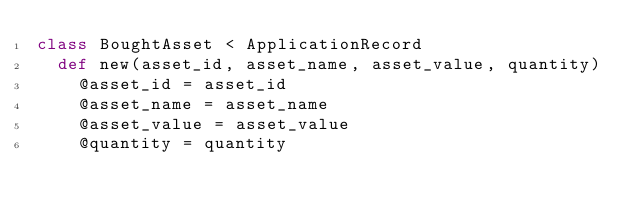<code> <loc_0><loc_0><loc_500><loc_500><_Ruby_>class BoughtAsset < ApplicationRecord
	def new(asset_id, asset_name, asset_value, quantity)
		@asset_id = asset_id
		@asset_name = asset_name
		@asset_value = asset_value
		@quantity = quantity</code> 